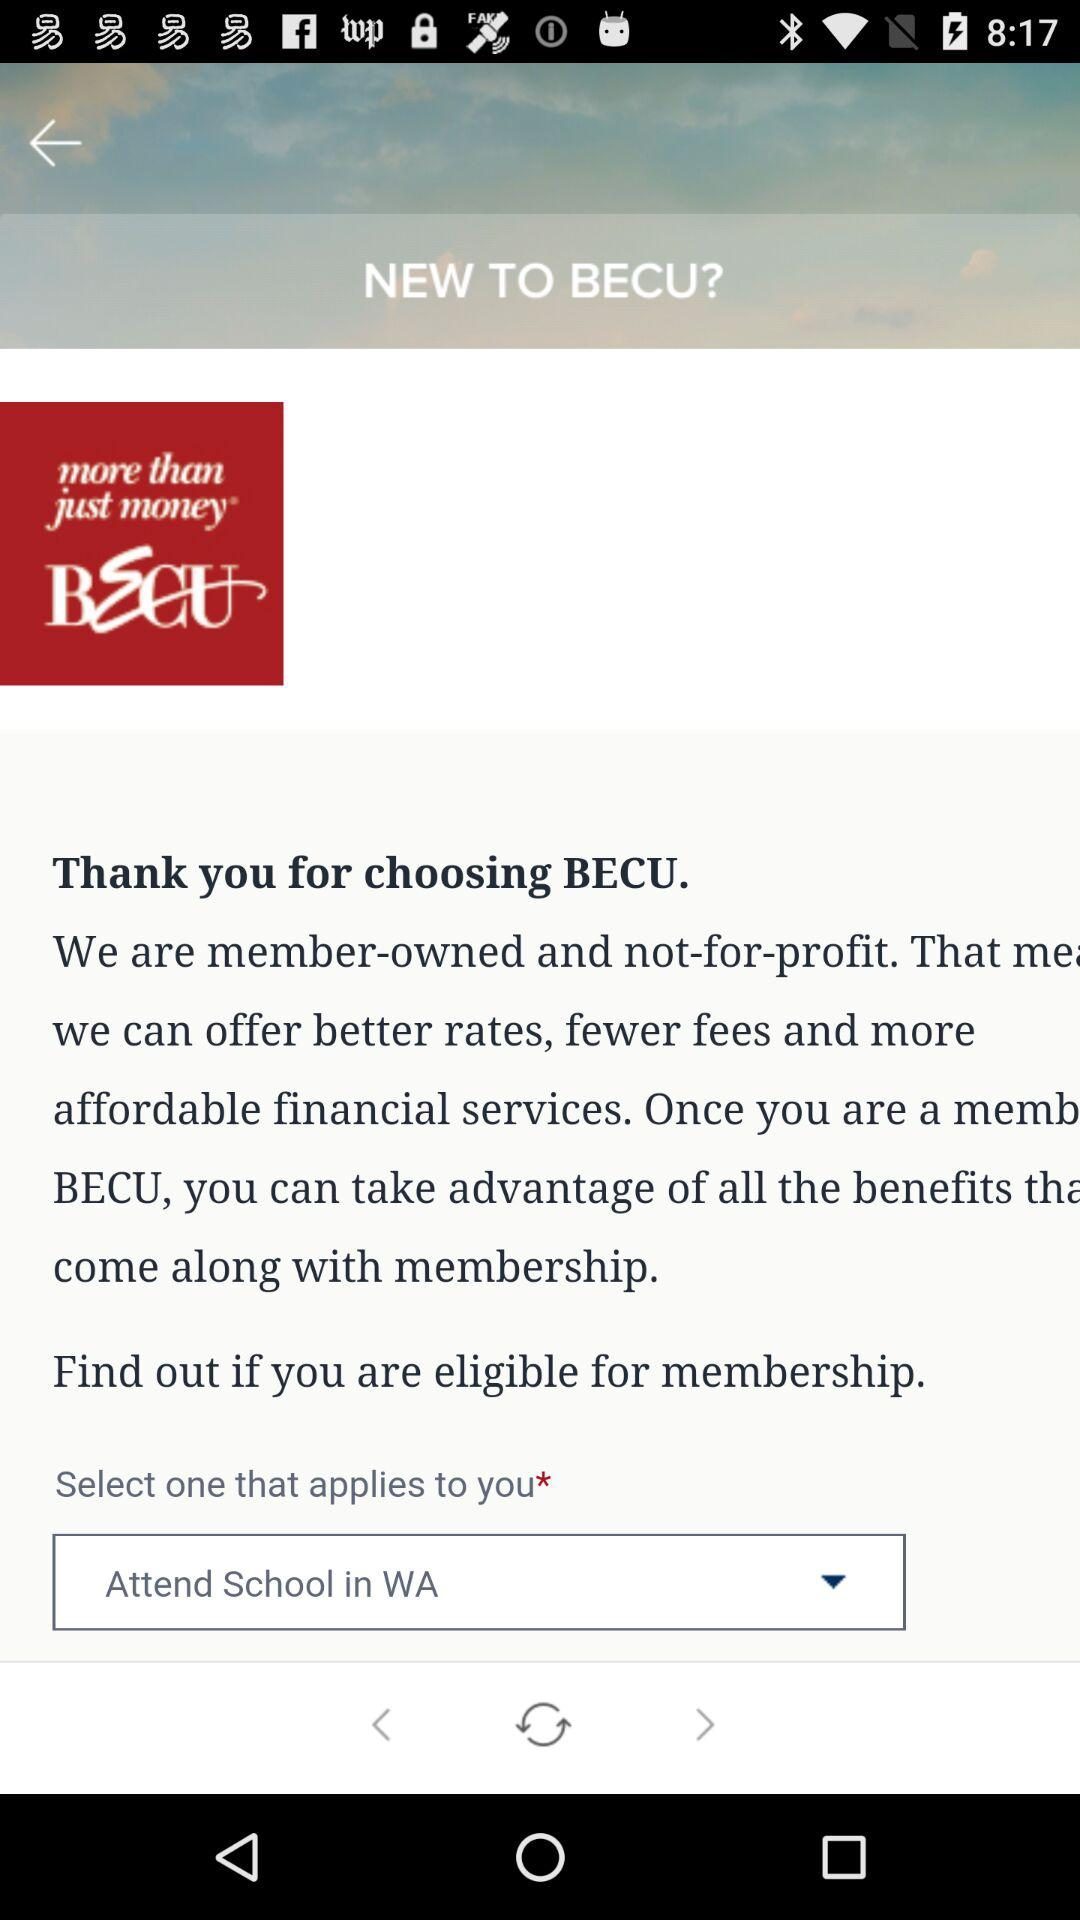What is the company name? The company name is BECU. 